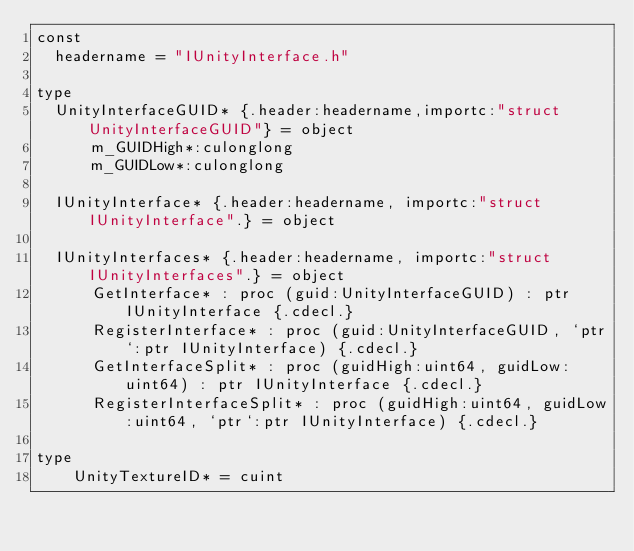Convert code to text. <code><loc_0><loc_0><loc_500><loc_500><_Nim_>const
  headername = "IUnityInterface.h"

type
  UnityInterfaceGUID* {.header:headername,importc:"struct UnityInterfaceGUID"} = object 
      m_GUIDHigh*:culonglong
      m_GUIDLow*:culonglong
 
  IUnityInterface* {.header:headername, importc:"struct IUnityInterface".} = object
  
  IUnityInterfaces* {.header:headername, importc:"struct IUnityInterfaces".} = object 
      GetInterface* : proc (guid:UnityInterfaceGUID) : ptr IUnityInterface {.cdecl.} 
      RegisterInterface* : proc (guid:UnityInterfaceGUID, `ptr`:ptr IUnityInterface) {.cdecl.} 
      GetInterfaceSplit* : proc (guidHigh:uint64, guidLow:uint64) : ptr IUnityInterface {.cdecl.} 
      RegisterInterfaceSplit* : proc (guidHigh:uint64, guidLow:uint64, `ptr`:ptr IUnityInterface) {.cdecl.} 

type
    UnityTextureID* = cuint
</code> 